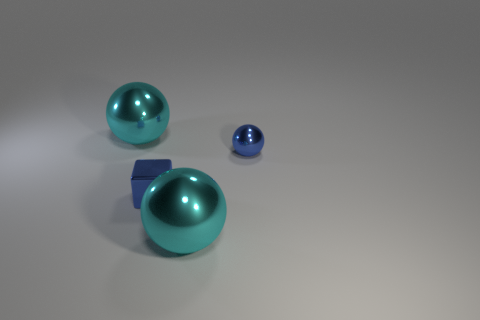Is the number of large metallic cubes less than the number of small things?
Provide a short and direct response. Yes. Is there anything else that is the same size as the blue metallic ball?
Keep it short and to the point. Yes. Is the number of small blue blocks greater than the number of small purple shiny cylinders?
Your answer should be very brief. Yes. What number of other things are the same color as the small shiny ball?
Offer a terse response. 1. Does the blue cube have the same material as the cyan thing right of the tiny blue shiny cube?
Make the answer very short. Yes. There is a large metallic thing behind the tiny blue metallic thing that is left of the small sphere; how many metal objects are to the left of it?
Your response must be concise. 0. Is the number of small blue metal blocks that are in front of the blue cube less than the number of cyan metallic spheres on the left side of the tiny ball?
Provide a short and direct response. Yes. What number of other objects are the same material as the small blue block?
Offer a terse response. 3. There is a blue ball that is the same size as the metal block; what material is it?
Keep it short and to the point. Metal. How many cyan things are either small shiny cubes or things?
Keep it short and to the point. 2. 